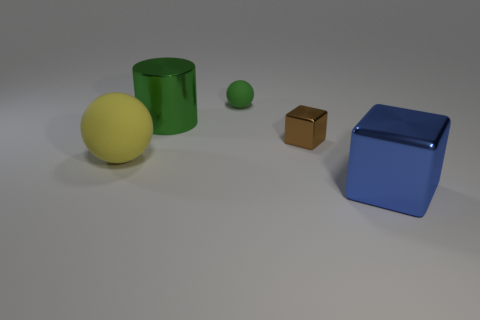There is a cylinder that is the same size as the yellow rubber object; what is it made of?
Your answer should be very brief. Metal. Are there any brown blocks of the same size as the yellow rubber object?
Keep it short and to the point. No. What is the tiny object that is behind the brown cube made of?
Provide a short and direct response. Rubber. Do the large cylinder left of the blue shiny cube and the big sphere have the same material?
Offer a very short reply. No. The green object that is the same size as the yellow object is what shape?
Offer a very short reply. Cylinder. What number of large shiny objects are the same color as the small metallic cube?
Your answer should be very brief. 0. Is the number of matte objects that are in front of the yellow rubber thing less than the number of tiny brown metal blocks that are right of the tiny green rubber thing?
Offer a very short reply. Yes. Are there any brown metal things in front of the blue metal object?
Your answer should be compact. No. Is there a cylinder that is right of the rubber ball that is behind the green object that is on the left side of the small green object?
Give a very brief answer. No. There is a brown thing that is behind the big blue thing; is it the same shape as the large blue thing?
Offer a very short reply. Yes. 